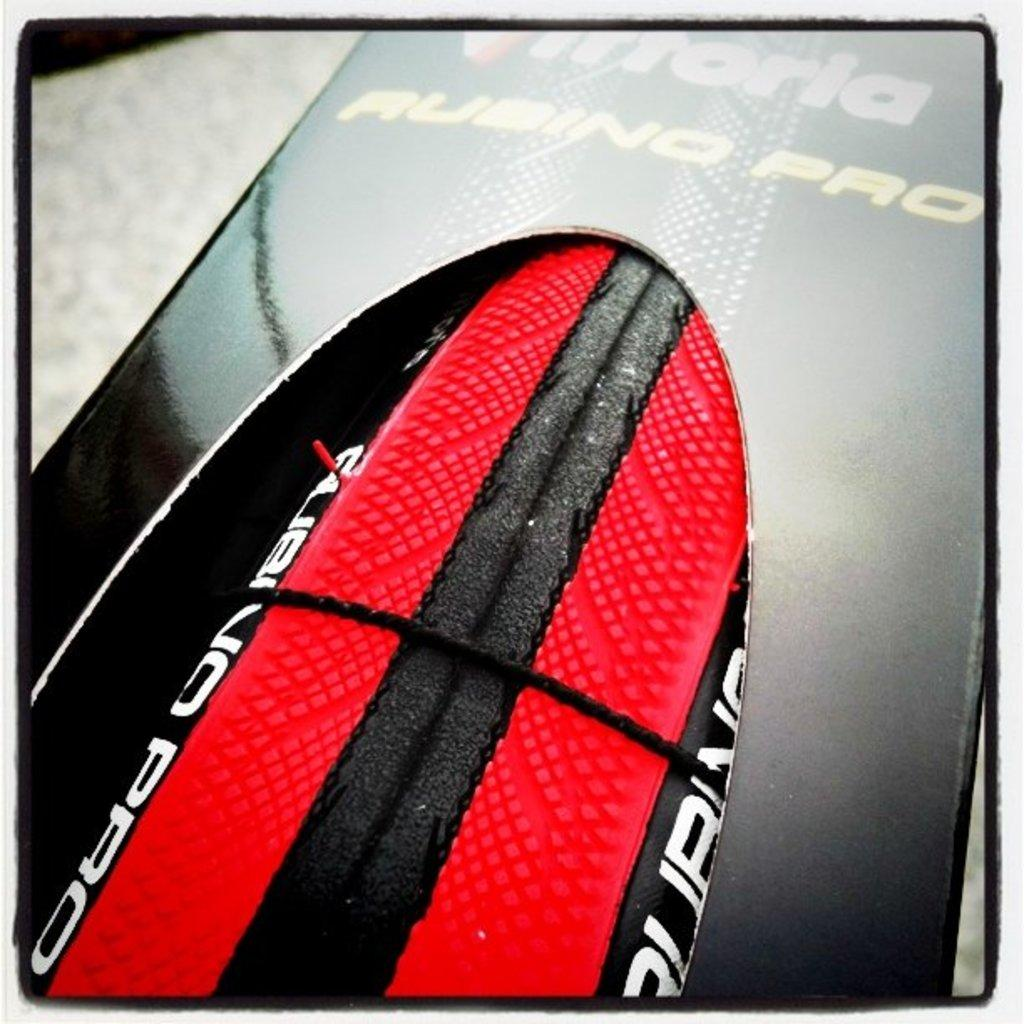What is the color of the box in the image? The box in the image is black. How many spiders are crawling on the black color box in the image? There are no spiders present in the image; it only shows a black color box. What scientific experiment is being conducted with the black color box in the image? There is no scientific experiment depicted in the image; it only shows a black color box. 